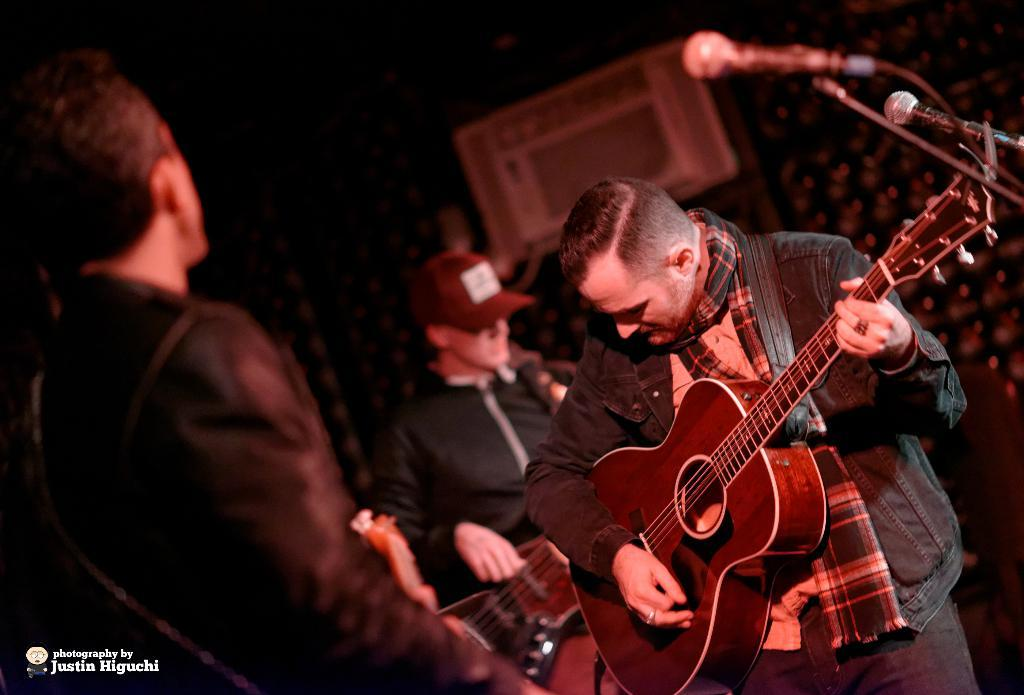How many people are in the image? There are three persons in the image. What is one person doing in the image? One person is standing and playing the guitar. What object is present in the image that is typically used for amplifying sound? There is a microphone in the image. What is the tall, adjustable stand in the image used for? There is a microphone stand in the image, which is used to hold and position the microphone. What direction is the person playing the guitar facing in the image? The facts provided do not specify the direction the person is facing, so it cannot be determined from the image. What type of credit card is the person holding in the image? There is no credit card present in the image; it features three persons, one of whom is playing the guitar. 